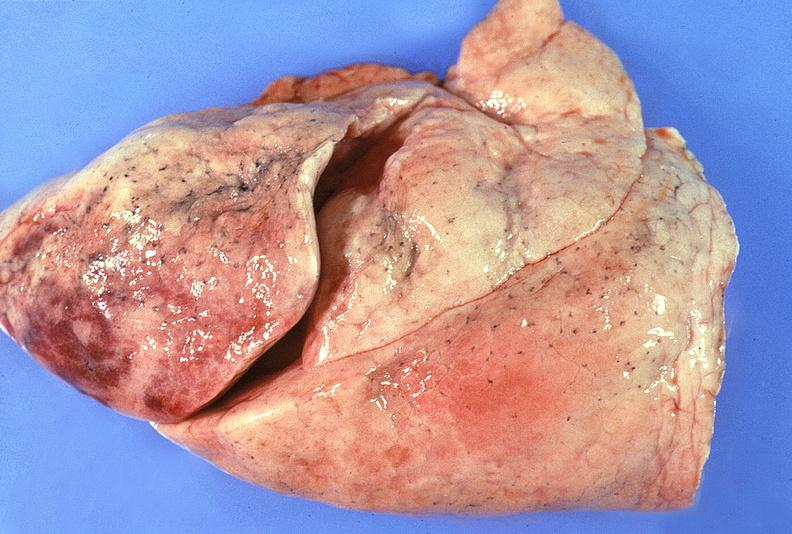where is this?
Answer the question using a single word or phrase. Lung 